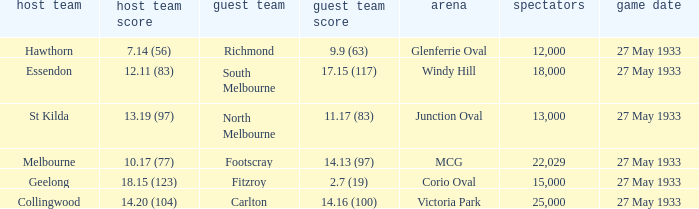During st kilda's home game, what was the number of people in the crowd? 13000.0. 